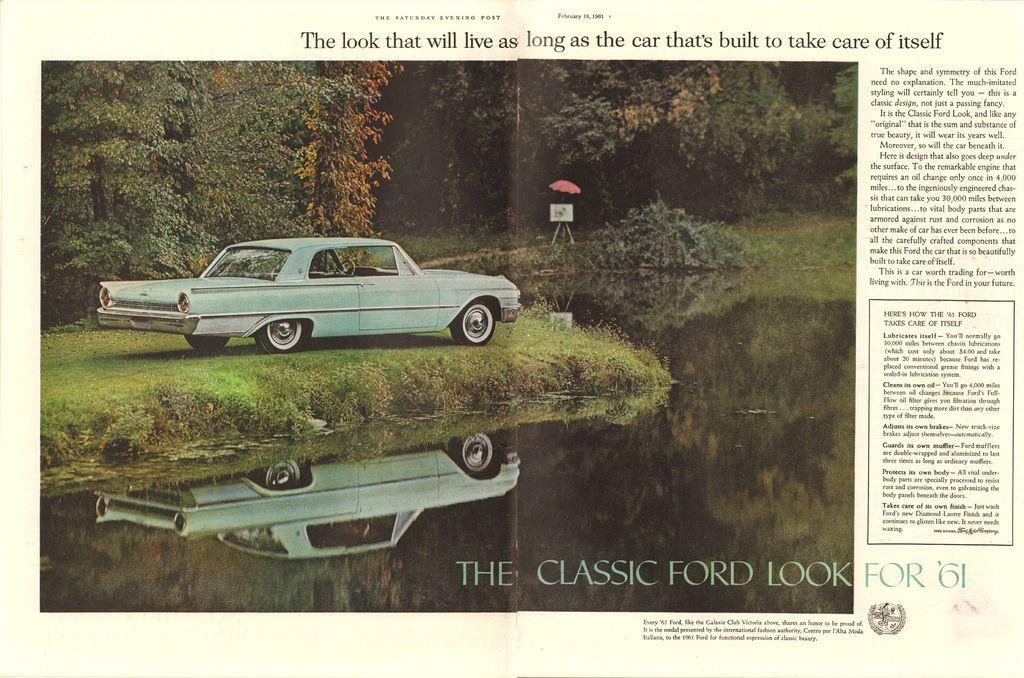What is the main subject of the image? There is an article in the image. What else can be seen in the image besides the article? There is a car, grass, water, reflections, an umbrella, a board, plants, and trees in the image. What is the car's position in the image? The car is in the image. What is the condition of the water in the image? There is water in the image. What is the purpose of the umbrella in the image? The umbrella is in the image. What is the board used for in the image? The board is in the image. What type of plants are present in the image? There are plants in the image. What is the condition of the trees in the image? There are trees in the image. What is written in the article in the image? Something is written in the article in the image. How does the sun affect the skate in the image? There is no skate present in the image, and the sun is not mentioned as a factor. What type of calculator is being used in the image? There is no calculator present in the image. 